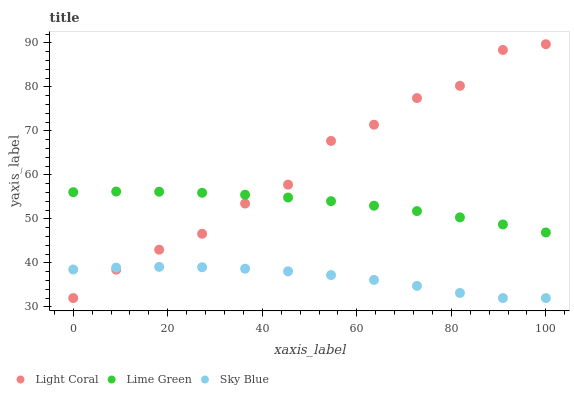Does Sky Blue have the minimum area under the curve?
Answer yes or no. Yes. Does Light Coral have the maximum area under the curve?
Answer yes or no. Yes. Does Lime Green have the minimum area under the curve?
Answer yes or no. No. Does Lime Green have the maximum area under the curve?
Answer yes or no. No. Is Lime Green the smoothest?
Answer yes or no. Yes. Is Light Coral the roughest?
Answer yes or no. Yes. Is Sky Blue the smoothest?
Answer yes or no. No. Is Sky Blue the roughest?
Answer yes or no. No. Does Light Coral have the lowest value?
Answer yes or no. Yes. Does Lime Green have the lowest value?
Answer yes or no. No. Does Light Coral have the highest value?
Answer yes or no. Yes. Does Lime Green have the highest value?
Answer yes or no. No. Is Sky Blue less than Lime Green?
Answer yes or no. Yes. Is Lime Green greater than Sky Blue?
Answer yes or no. Yes. Does Light Coral intersect Sky Blue?
Answer yes or no. Yes. Is Light Coral less than Sky Blue?
Answer yes or no. No. Is Light Coral greater than Sky Blue?
Answer yes or no. No. Does Sky Blue intersect Lime Green?
Answer yes or no. No. 